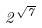Convert formula to latex. <formula><loc_0><loc_0><loc_500><loc_500>2 ^ { \sqrt { 7 } }</formula> 